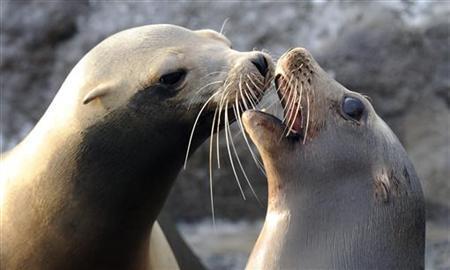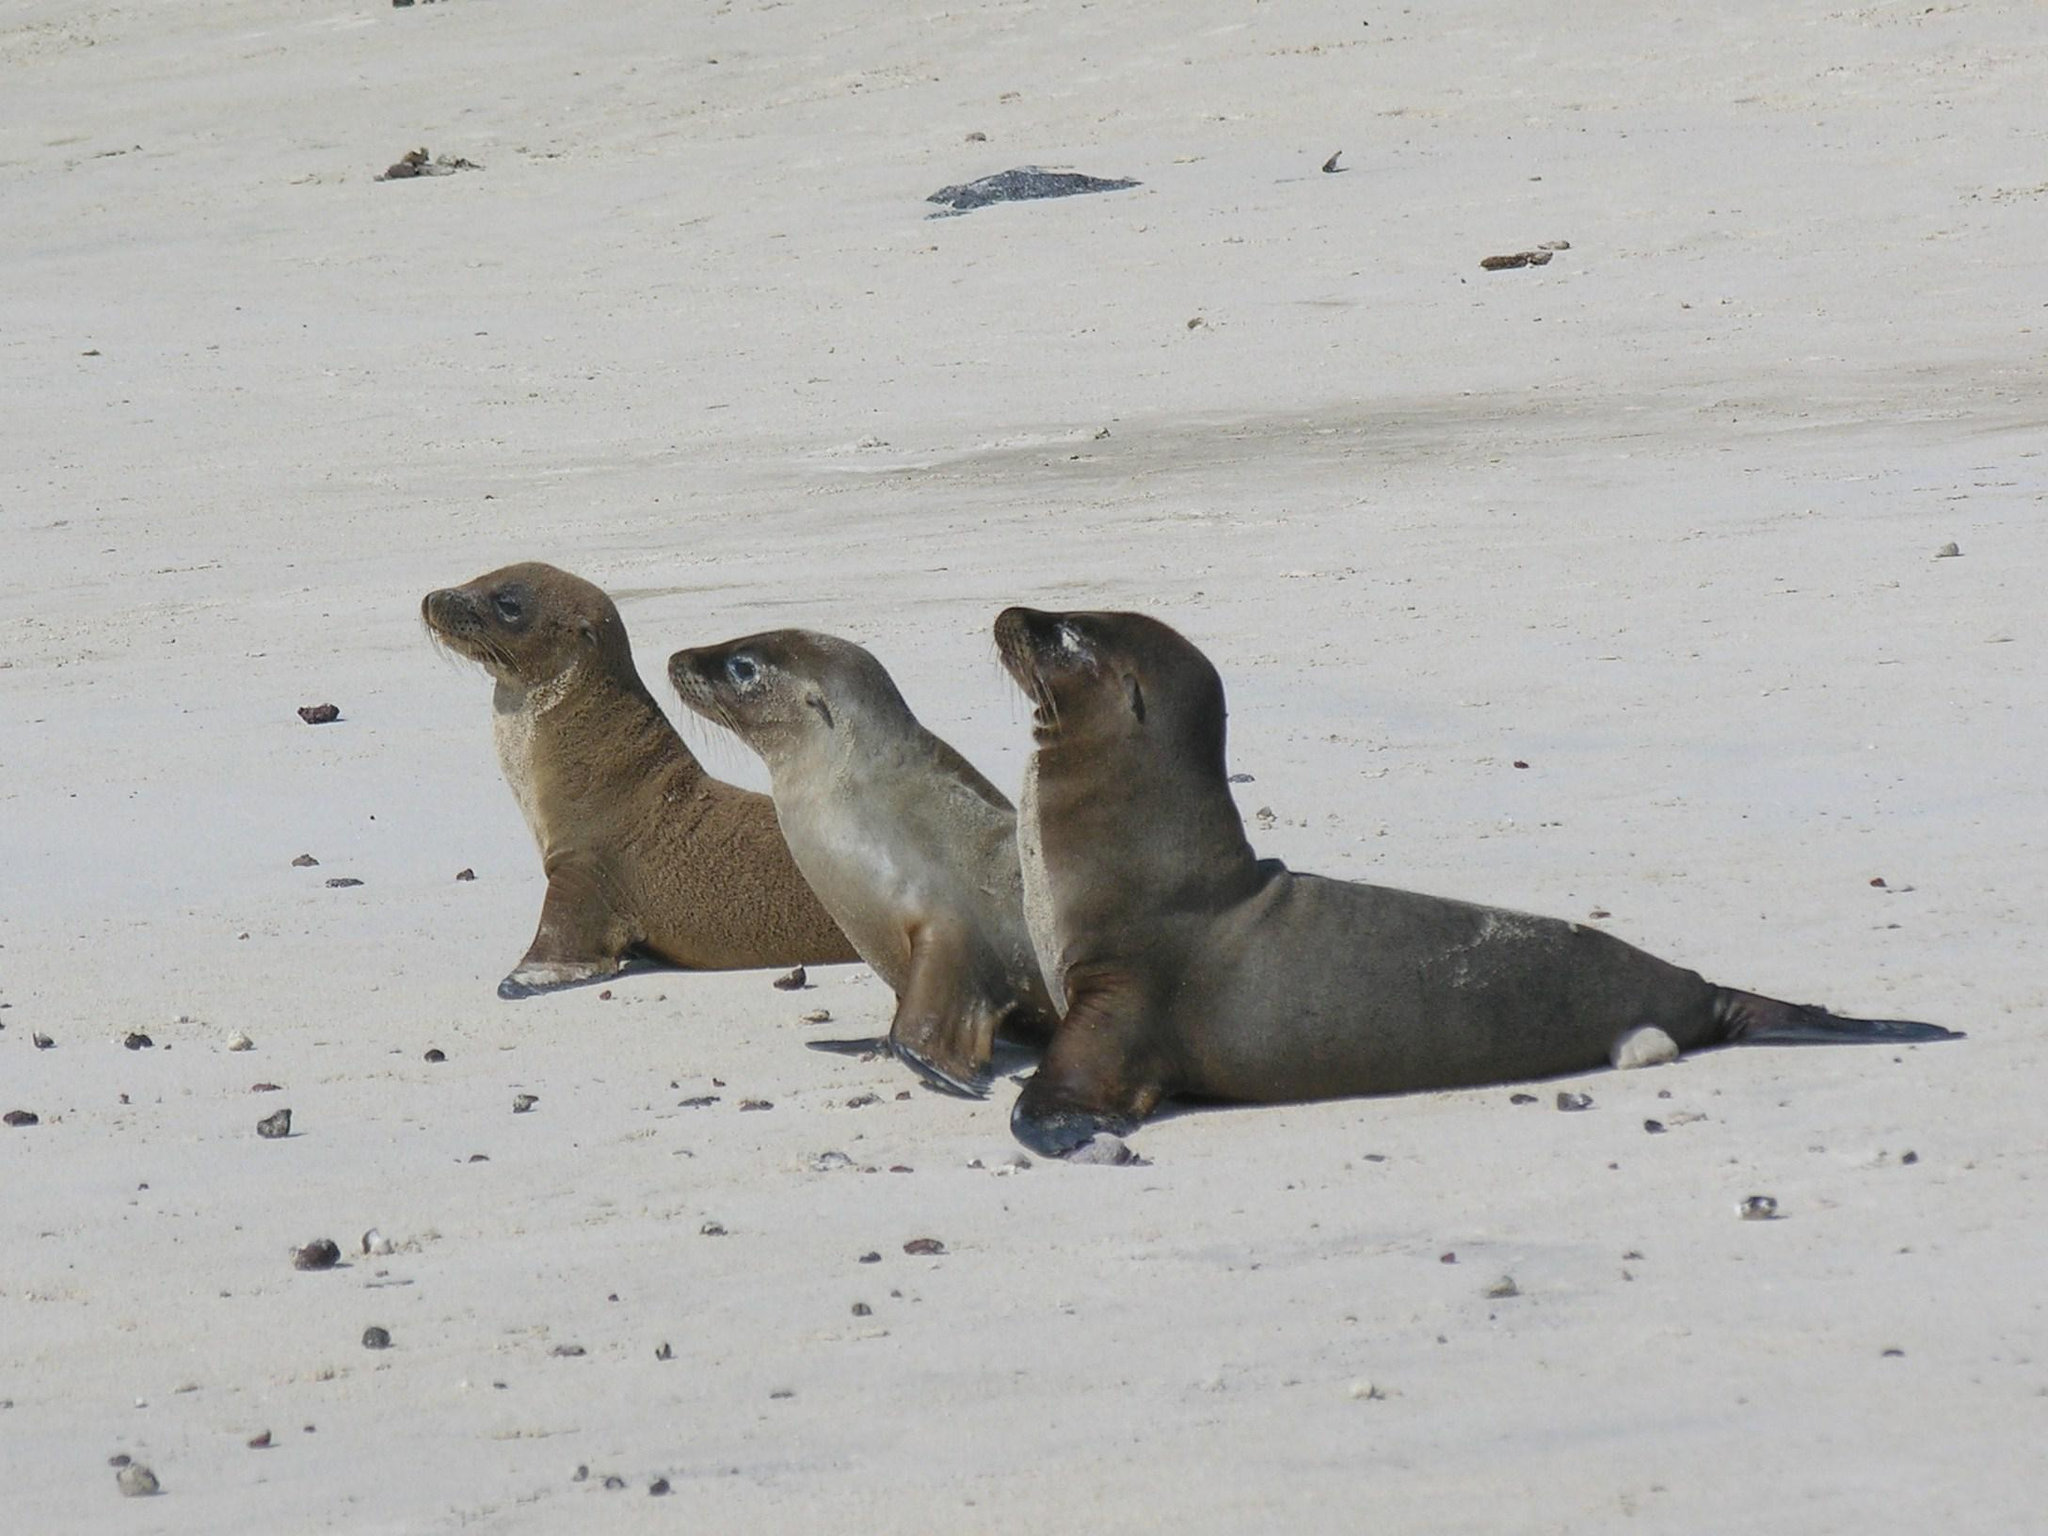The first image is the image on the left, the second image is the image on the right. Evaluate the accuracy of this statement regarding the images: "There are 5 sea lions in total.". Is it true? Answer yes or no. Yes. The first image is the image on the left, the second image is the image on the right. Considering the images on both sides, is "The left image contains exactly two seals." valid? Answer yes or no. Yes. 